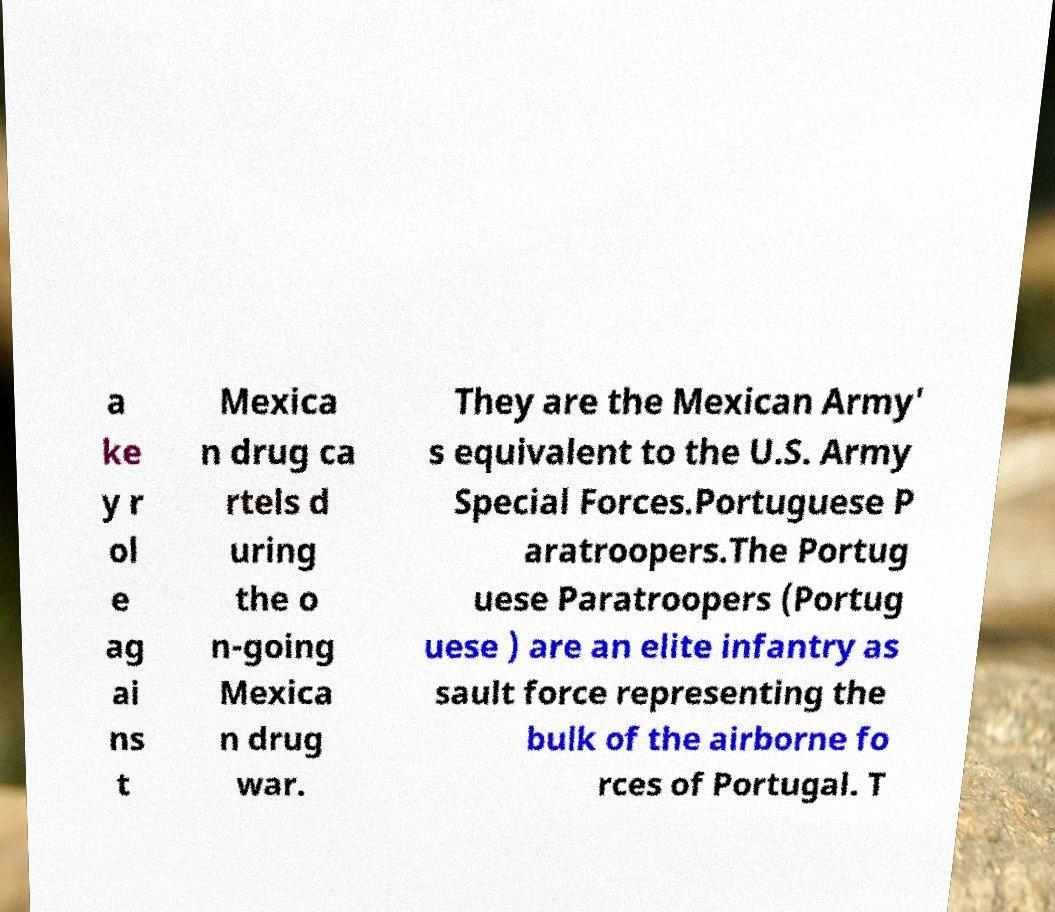Please identify and transcribe the text found in this image. a ke y r ol e ag ai ns t Mexica n drug ca rtels d uring the o n-going Mexica n drug war. They are the Mexican Army' s equivalent to the U.S. Army Special Forces.Portuguese P aratroopers.The Portug uese Paratroopers (Portug uese ) are an elite infantry as sault force representing the bulk of the airborne fo rces of Portugal. T 